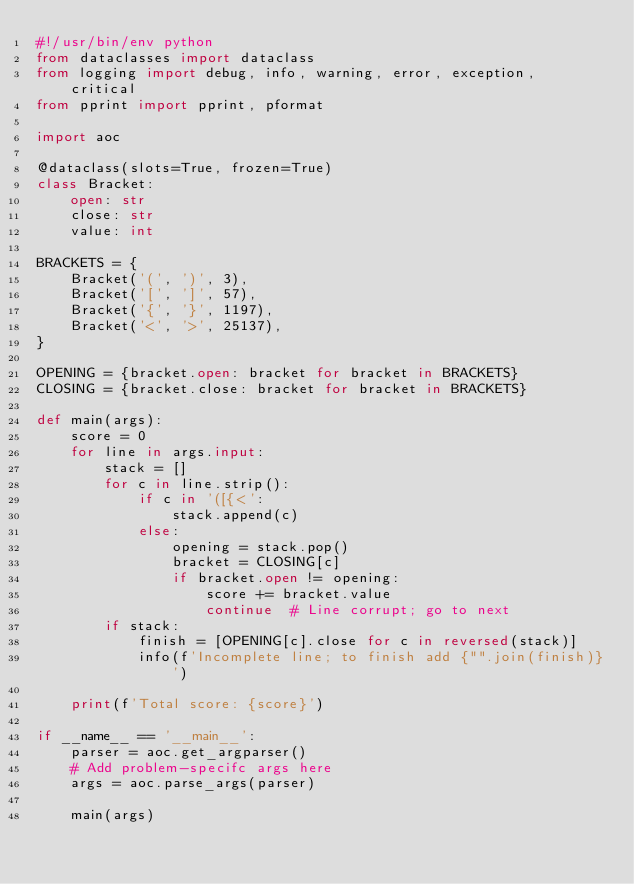Convert code to text. <code><loc_0><loc_0><loc_500><loc_500><_Python_>#!/usr/bin/env python
from dataclasses import dataclass
from logging import debug, info, warning, error, exception, critical
from pprint import pprint, pformat

import aoc

@dataclass(slots=True, frozen=True)
class Bracket:
	open: str
	close: str
	value: int

BRACKETS = {
	Bracket('(', ')', 3),
	Bracket('[', ']', 57),
	Bracket('{', '}', 1197),
	Bracket('<', '>', 25137),
}

OPENING = {bracket.open: bracket for bracket in BRACKETS}
CLOSING = {bracket.close: bracket for bracket in BRACKETS}

def main(args):
	score = 0
	for line in args.input:
		stack = []
		for c in line.strip():
			if c in '([{<':
				stack.append(c)
			else:
				opening = stack.pop()
				bracket = CLOSING[c]
				if bracket.open != opening:
					score += bracket.value
					continue  # Line corrupt; go to next
		if stack:
			finish = [OPENING[c].close for c in reversed(stack)]
			info(f'Incomplete line; to finish add {"".join(finish)}')
		
	print(f'Total score: {score}')

if __name__ == '__main__':
	parser = aoc.get_argparser()
	# Add problem-specifc args here
	args = aoc.parse_args(parser)
	
	main(args)</code> 